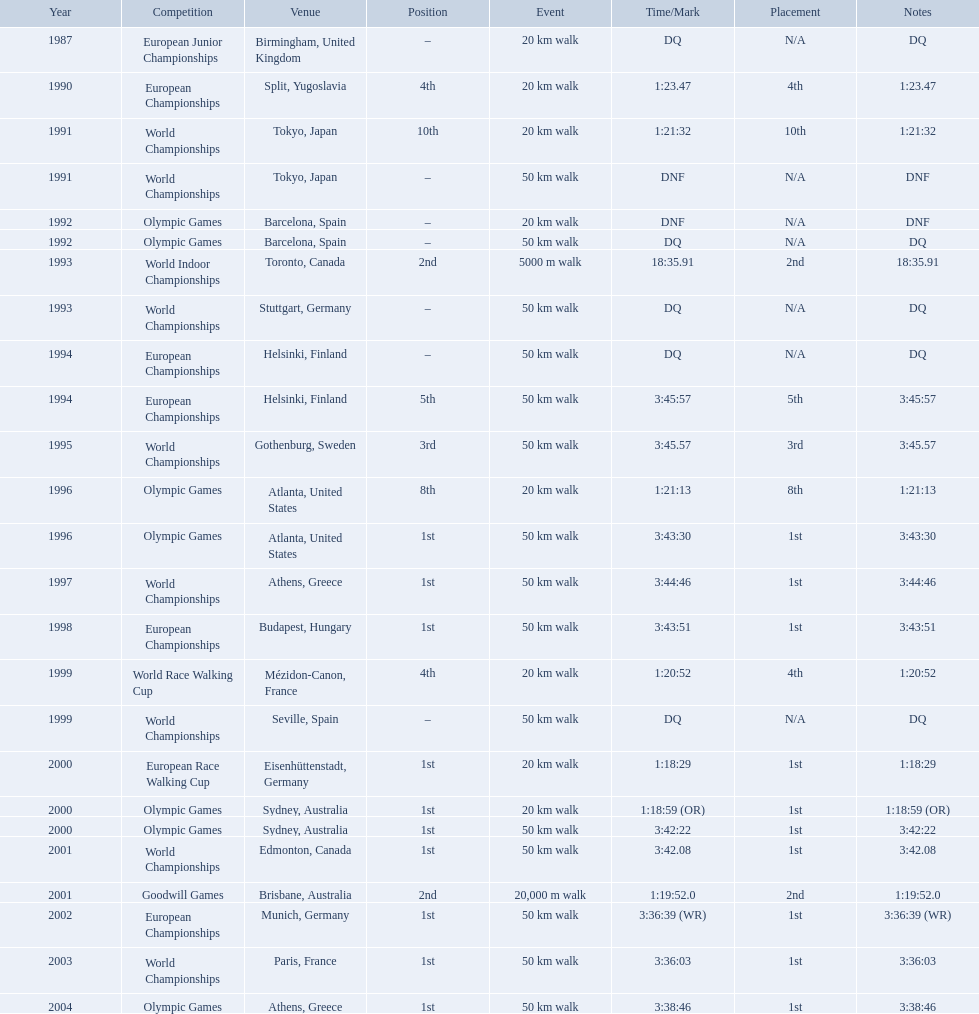What are the notes DQ, 1:23.47, 1:21:32, DNF, DNF, DQ, 18:35.91, DQ, DQ, 3:45:57, 3:45.57, 1:21:13, 3:43:30, 3:44:46, 3:43:51, 1:20:52, DQ, 1:18:29, 1:18:59 (OR), 3:42:22, 3:42.08, 1:19:52.0, 3:36:39 (WR), 3:36:03, 3:38:46. What time does the notes for 2004 show 3:38:46. 